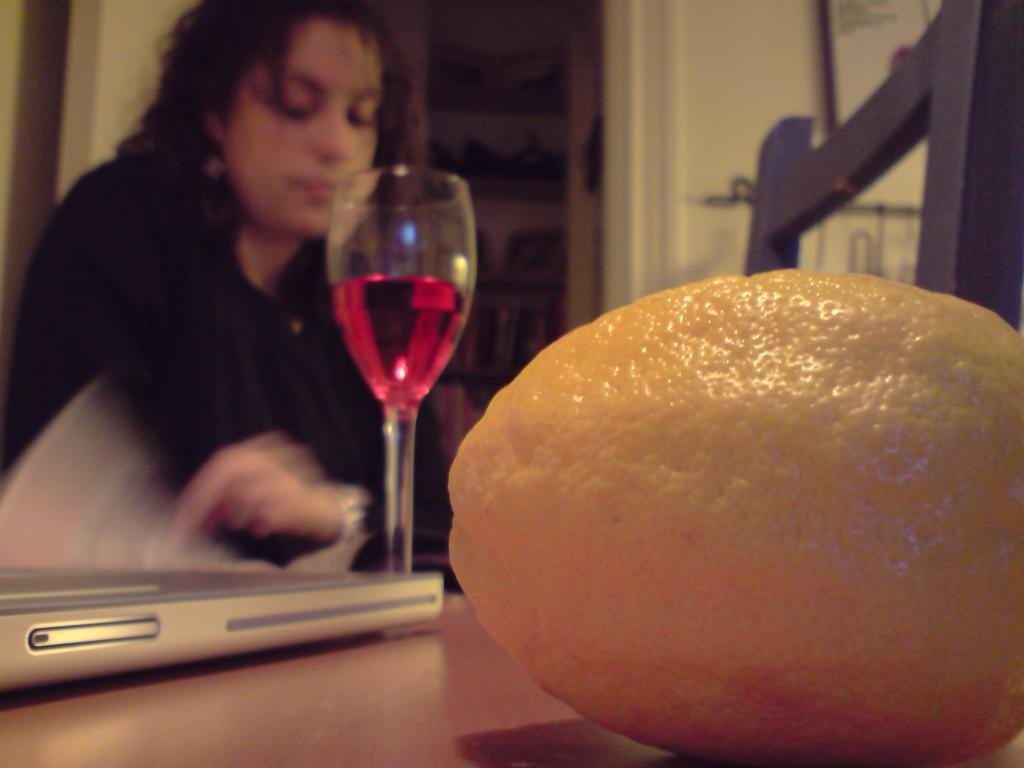What type of fruit is in the image? There is a lemon in the image. What object is hanging in the image? There is a mobile in the image. What type of drink is on the table in the image? There is a glass of wine on the table in the image. Who is present in the image? There is a person sitting in the image. What piece of furniture is in the image? There is a chair in the image. What can be seen in the background of the image? There are some items visible in the background of the image. What type of stamp can be seen on the person's forehead in the image? There is no stamp present on the person's forehead in the image. What type of bird is perched on the chair in the image? There is no bird, specifically a wren, present on the chair in the image. 